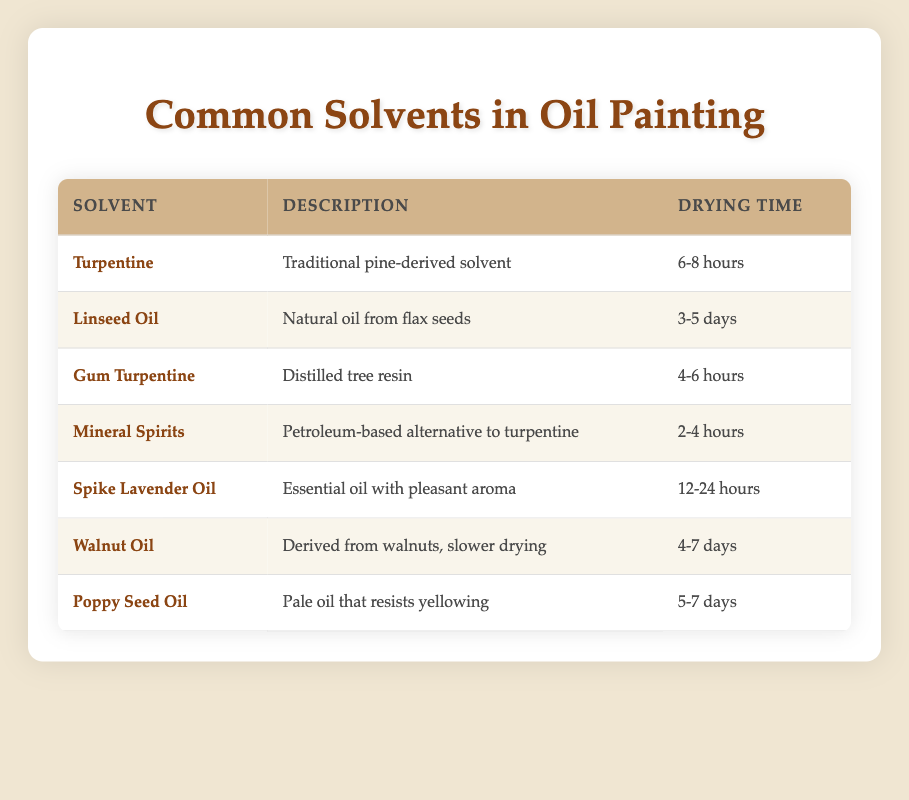What is the drying time of Turpentine? The table lists the drying time of Turpentine under the "Drying Time" column, showing that it is 6-8 hours.
Answer: 6-8 hours Which solvent has the longest drying time? To find the longest drying time, we look at the "Drying Time" column and see that Linseed Oil, Walnut Oil, and Poppy Seed Oil have drying times ranging from 3-5 days and beyond. The longest is Walnut Oil at 4-7 days.
Answer: Walnut Oil Is Spike Lavender Oil faster drying than Mineral Spirits? We need to compare the drying times of Spike Lavender Oil (12-24 hours) and Mineral Spirits (2-4 hours) directly from the "Drying Time" column. Since 2-4 hours is shorter than 12-24 hours, Mineral Spirits dry faster.
Answer: No What is the average drying time of all the solvents? To calculate the average drying time, we need to convert time ranges to a single value. We take the average of each: Turpentine (7), Linseed Oil (4), Gum Turpentine (5), Mineral Spirits (3), Spike Lavender Oil (18), Walnut Oil (5.5), and Poppy Seed Oil (6). Now we sum these values (7 + 4 + 5 + 3 + 18 + 5.5 + 6) = 48.5. There are 7 solvents, so the average is 48.5/7 ≈ 6.93 hours.
Answer: Approximately 6.93 hours Does any solvent listed have a drying time of less than 5 hours? By checking the "Drying Time" column, we can see if any solvents list times under 5 hours. Mineral Spirits (2-4 hours) confirms that at least one does meet this condition.
Answer: Yes 